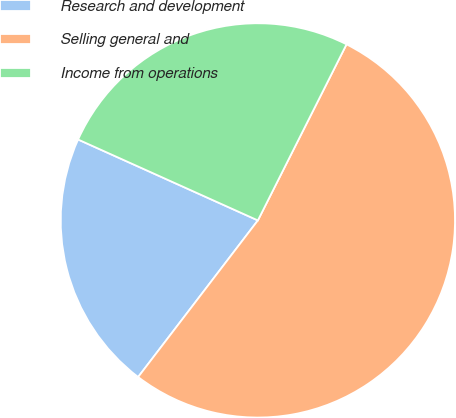<chart> <loc_0><loc_0><loc_500><loc_500><pie_chart><fcel>Research and development<fcel>Selling general and<fcel>Income from operations<nl><fcel>21.34%<fcel>52.96%<fcel>25.69%<nl></chart> 